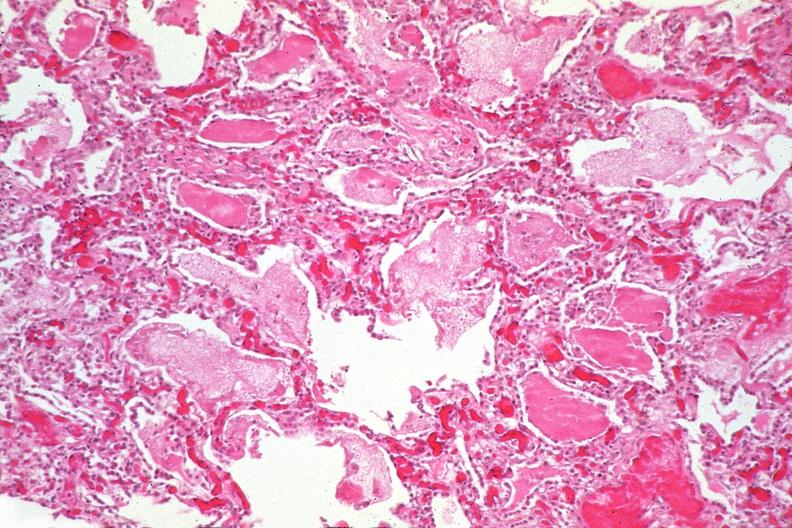does brain, cryptococcal meningitis, pas show lung, pneumocystis pneumonia?
Answer the question using a single word or phrase. No 